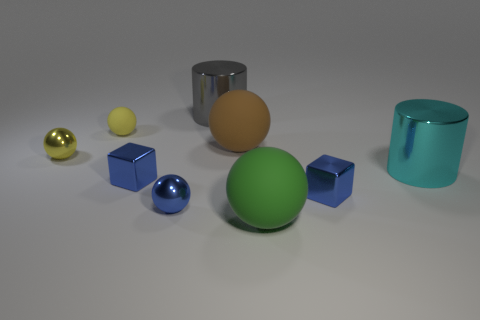Subtract all tiny blue spheres. How many spheres are left? 4 Add 1 small blue shiny objects. How many objects exist? 10 Subtract 1 cylinders. How many cylinders are left? 1 Subtract all spheres. How many objects are left? 4 Subtract all blue spheres. How many spheres are left? 4 Subtract 1 green balls. How many objects are left? 8 Subtract all brown spheres. Subtract all cyan cylinders. How many spheres are left? 4 Subtract all purple spheres. How many gray cylinders are left? 1 Subtract all large green matte things. Subtract all tiny matte objects. How many objects are left? 7 Add 2 tiny rubber things. How many tiny rubber things are left? 3 